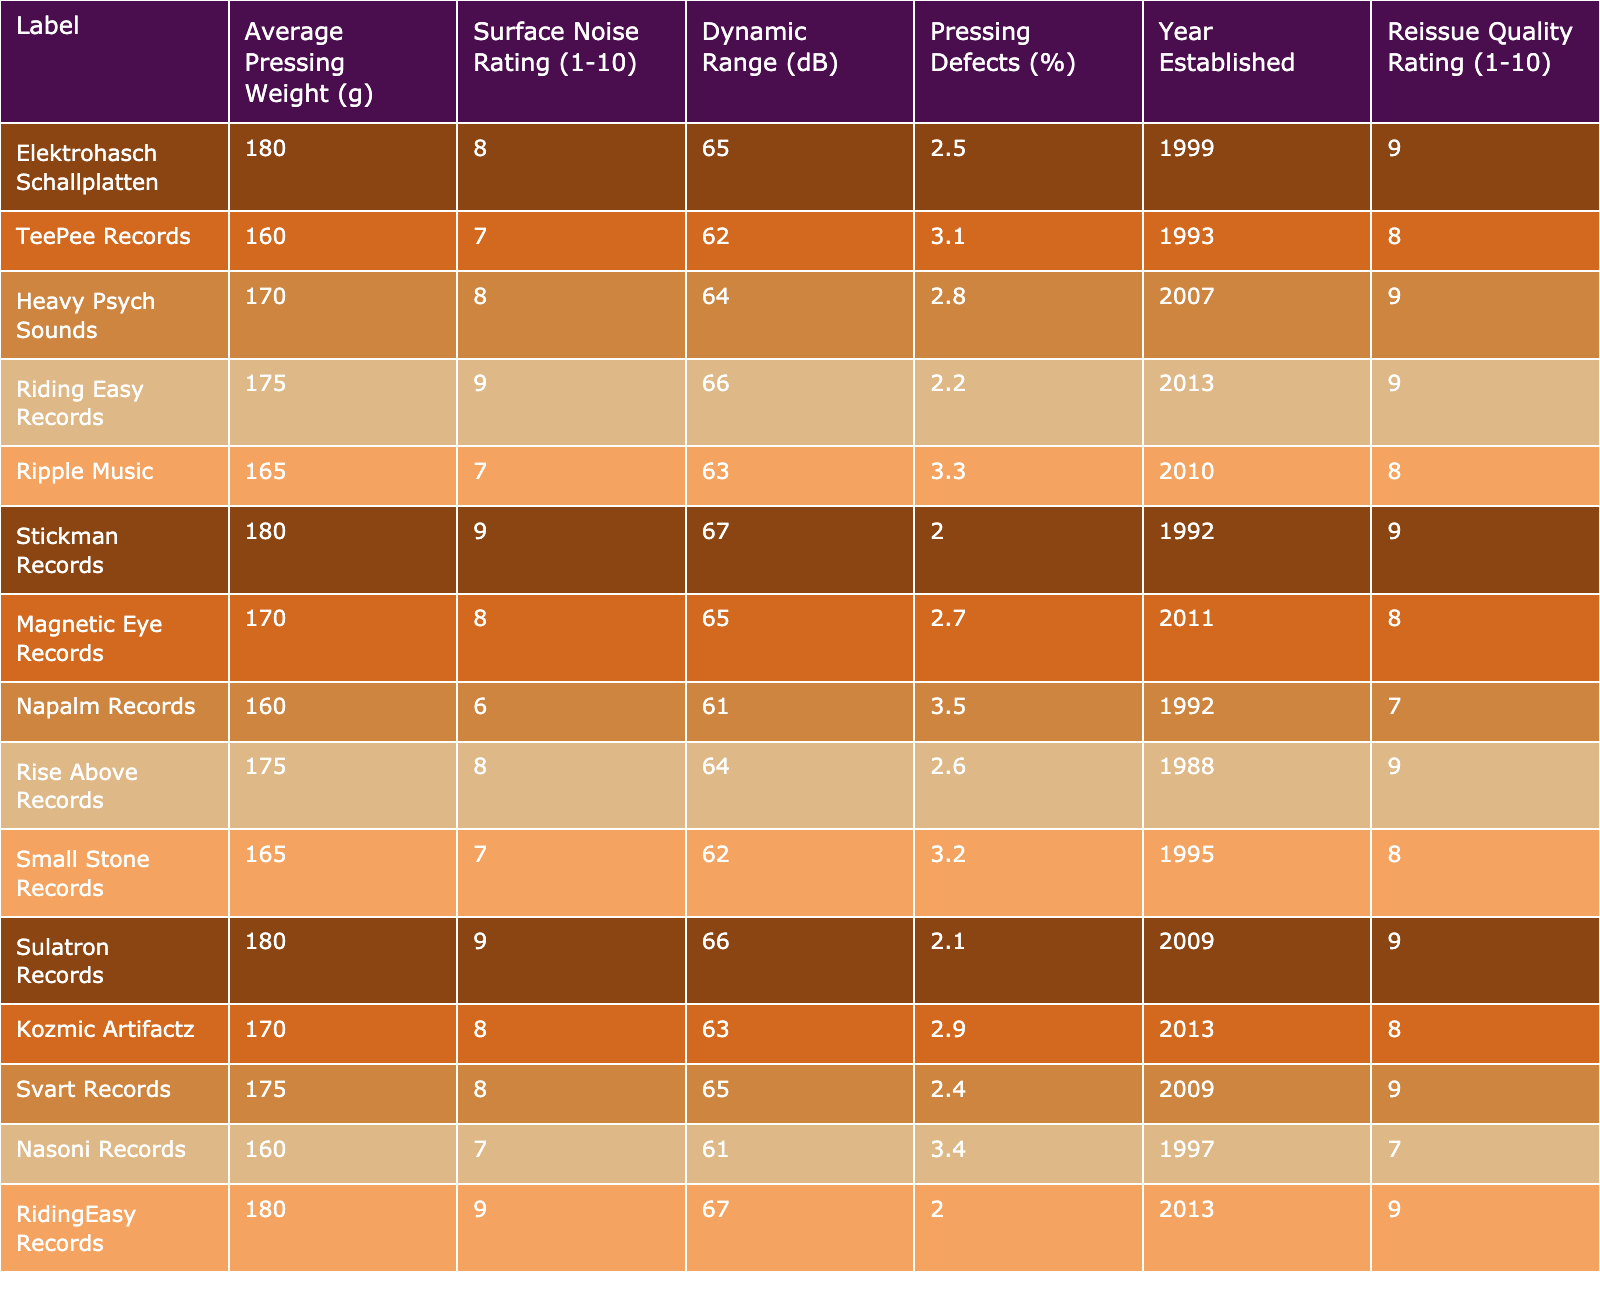What is the average pressing weight of the labels listed? To find the average pressing weight, sum the average weights of all the labels (180 + 160 + 170 + 175 + 165 + 180 + 170 + 160 + 175 + 165 + 180 + 170 + 175 + 160 + 180) which equals 2,532 grams. Then divide by the number of labels, which is 15. Thus, the average pressing weight is 2,532 / 15 = 168.8 grams.
Answer: 168.8 grams Which label has the lowest surface noise rating? By scanning through the Surface Noise Rating column, the lowest rating of 6 belongs to Napalm Records.
Answer: Napalm Records How many labels have a pressing defect percentage less than 3%? From the Pressing Defects (%) column, the labels with defect percentages less than 3% are Elektrohasch Schallplatten, Riding Easy Records, Stickman Records, and Sulatron Records. There are 4 such labels.
Answer: 4 What is the maximum dynamic range number for the labels? Looking through the Dynamic Range (dB) column, the highest value is 67, which belongs to both Riding Easy Records and Stickman Records.
Answer: 67 dB Which label established after 2005 has the highest reissue quality rating? First, identify the labels established after 2005: Heavy Psych Sounds (2007), Ripple Music (2010), Magnetic Eye Records (2011), and Riding Easy Records (2013). Among these, Riding Easy Records has the highest reissue quality rating of 9.
Answer: Riding Easy Records Are there any labels that have a surface noise rating of 10 or higher? All labels in the table have surface noise ratings that do not exceed 9. Therefore, the answer is no, there are no labels with a rating of 10 or above.
Answer: No What is the difference in average pressing weight between the label with the highest and lowest pressing weight? The highest average pressing weight is 180 grams (Elektrohasch Schallplatten, Stickman Records, RidingEasy Records) and the lowest is 160 grams (Napalm Records, TeePee Records, Nasoni Records). The difference is 180 - 160 = 20 grams.
Answer: 20 grams Which label has the best overall score combining surface noise, dynamic range, and pressing defects? This is subjective, but combining the metrics, the lowest surface noise and pressing defects ratings and highest dynamic range give the best overall impression. Riding Easy Records and Stickman Records both excel in these combined criteria with scores of (9 + 67 - 2.2 = 73.8) and (9 + 67 - 2.0 = 74.0), respectively. Stickman Records has the slight edge.
Answer: Stickman Records 